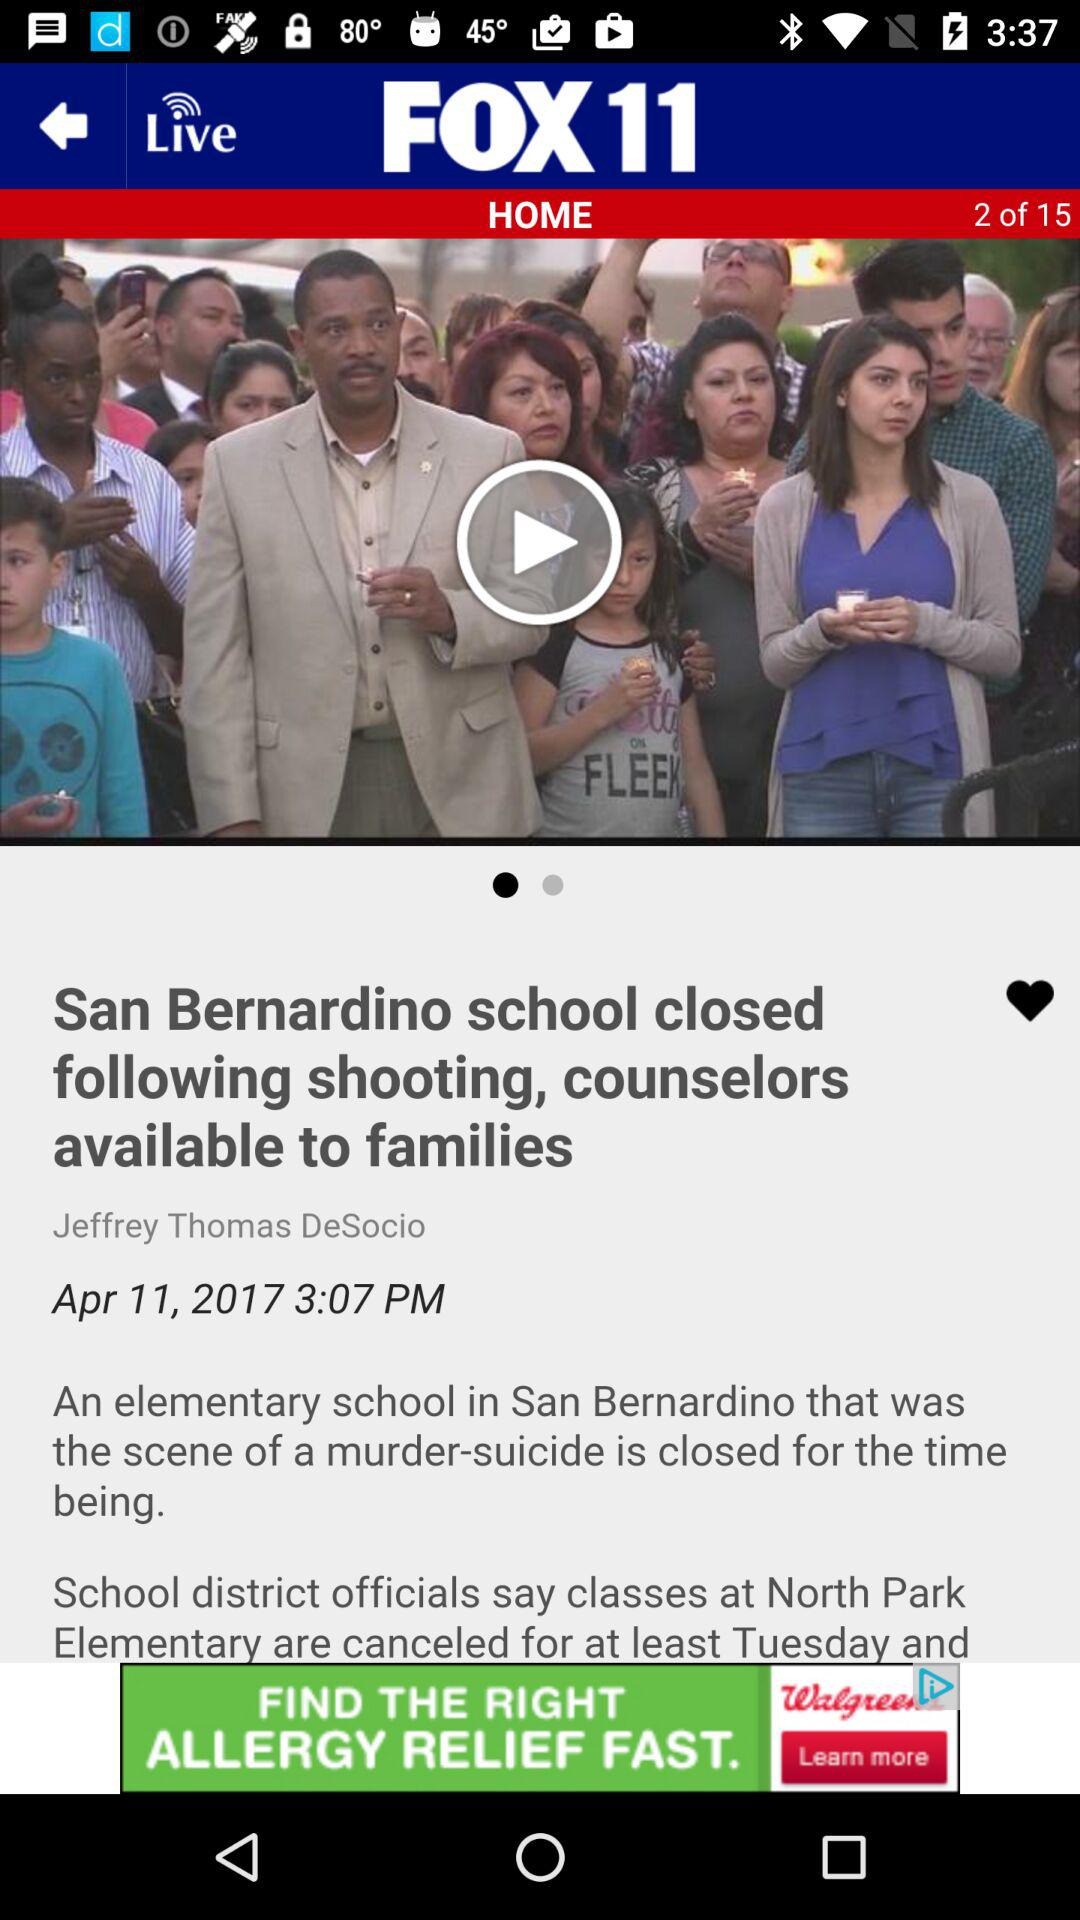What article am I on? You are on the 2nd article. 